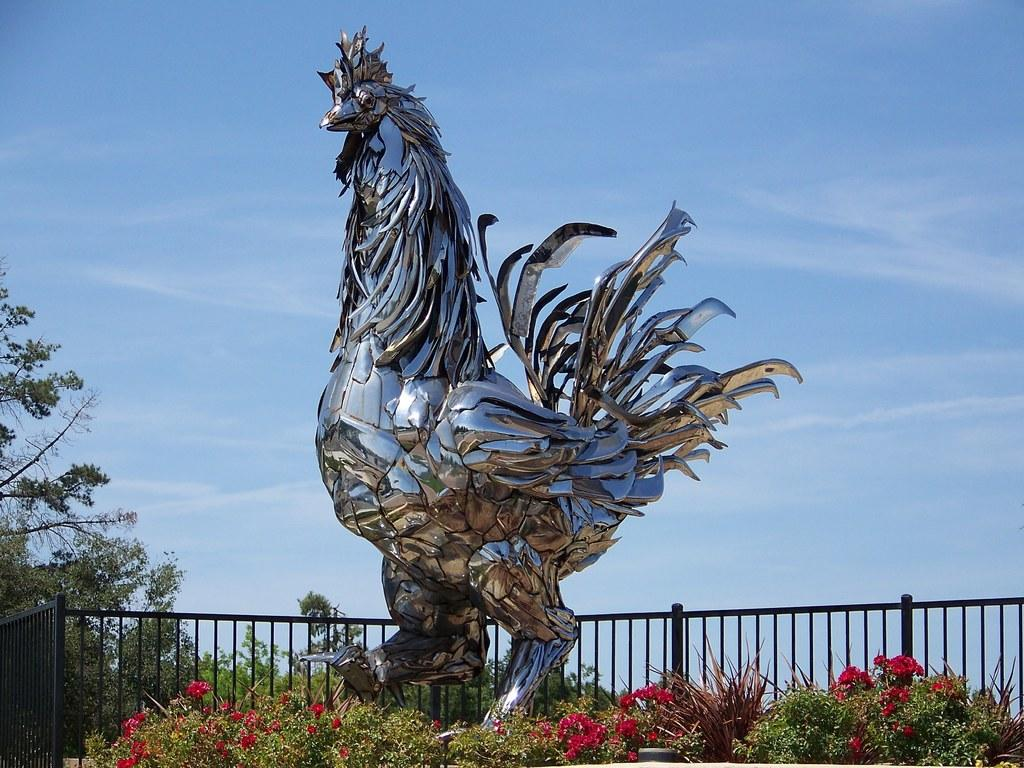What is the main subject of the image? There is a sculpture in the image. What other objects can be seen in the image? There are grills, plants, flowers, and trees in the image. What is visible in the background of the image? The sky is visible in the image, and clouds are present in the sky. What type of whip is being used to clean the sculpture in the image? There is no whip present in the image, and the sculpture is not being cleaned. 